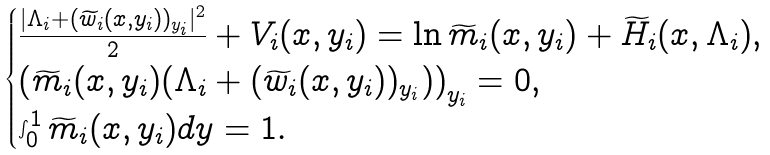Convert formula to latex. <formula><loc_0><loc_0><loc_500><loc_500>\begin{cases} \frac { | \Lambda _ { i } + ( \widetilde { w } _ { i } ( x , y _ { i } ) ) _ { y _ { i } } | ^ { 2 } } { 2 } + V _ { i } ( x , y _ { i } ) = \ln \widetilde { m } _ { i } ( x , y _ { i } ) + \widetilde { H } _ { i } ( x , \Lambda _ { i } ) , \\ \left ( \widetilde { m } _ { i } ( x , y _ { i } ) ( \Lambda _ { i } + ( \widetilde { w } _ { i } ( x , y _ { i } ) ) _ { y _ { i } } ) \right ) _ { y _ { i } } = 0 , \\ \int _ { 0 } ^ { 1 } \widetilde { m } _ { i } ( x , y _ { i } ) d y = 1 . \end{cases}</formula> 